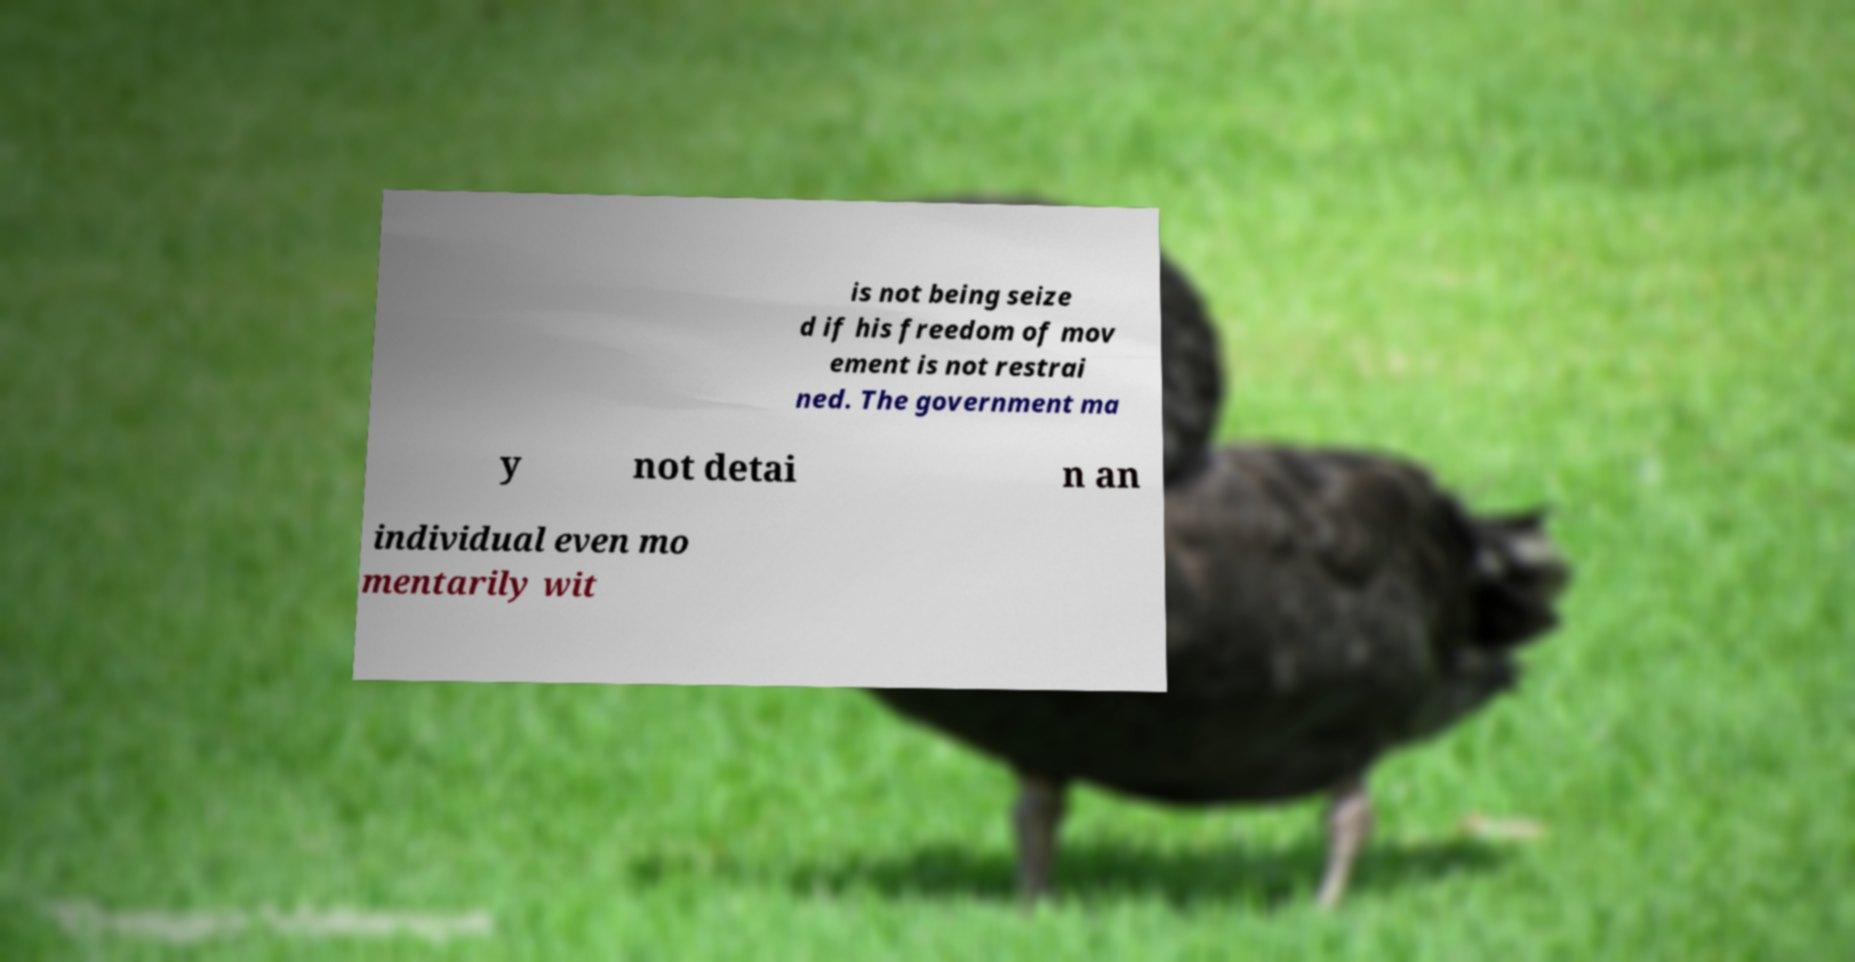I need the written content from this picture converted into text. Can you do that? is not being seize d if his freedom of mov ement is not restrai ned. The government ma y not detai n an individual even mo mentarily wit 